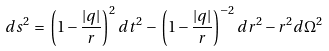<formula> <loc_0><loc_0><loc_500><loc_500>d s ^ { 2 } \, = \, \left ( 1 - \frac { | q | } { r } \right ) ^ { 2 } d t ^ { 2 } \, - \, \left ( 1 - \frac { | q | } { r } \right ) ^ { - 2 } d r ^ { 2 } - r ^ { 2 } d \Omega ^ { 2 }</formula> 